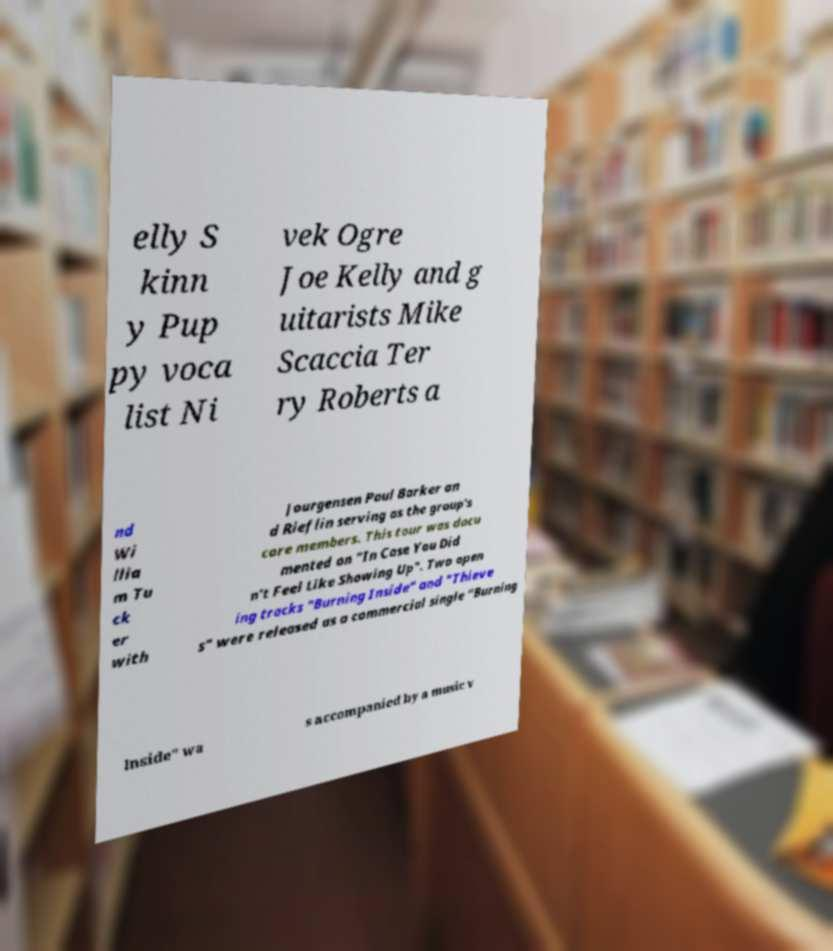Please identify and transcribe the text found in this image. elly S kinn y Pup py voca list Ni vek Ogre Joe Kelly and g uitarists Mike Scaccia Ter ry Roberts a nd Wi llia m Tu ck er with Jourgensen Paul Barker an d Rieflin serving as the group's core members. This tour was docu mented on "In Case You Did n't Feel Like Showing Up". Two open ing tracks "Burning Inside" and "Thieve s" were released as a commercial single "Burning Inside" wa s accompanied by a music v 